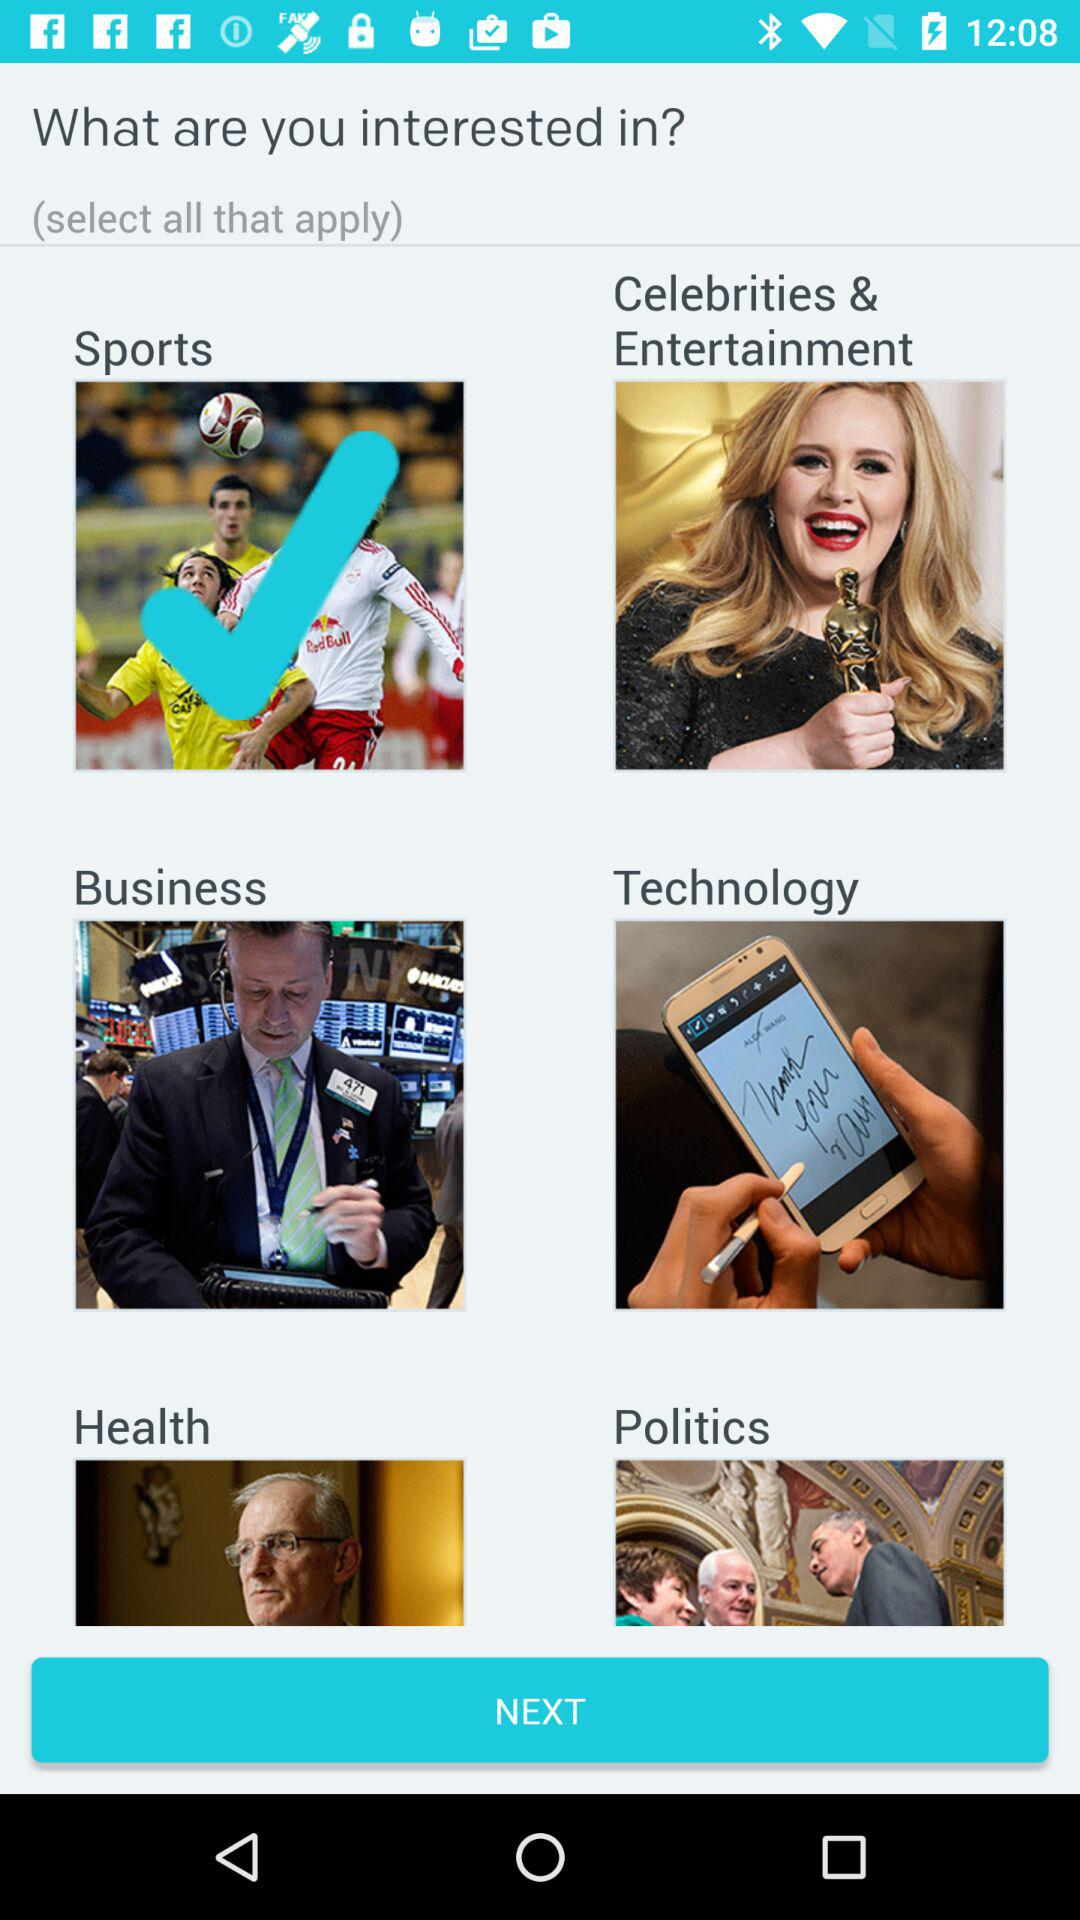How many interest options are there for the user to select?
Answer the question using a single word or phrase. 6 